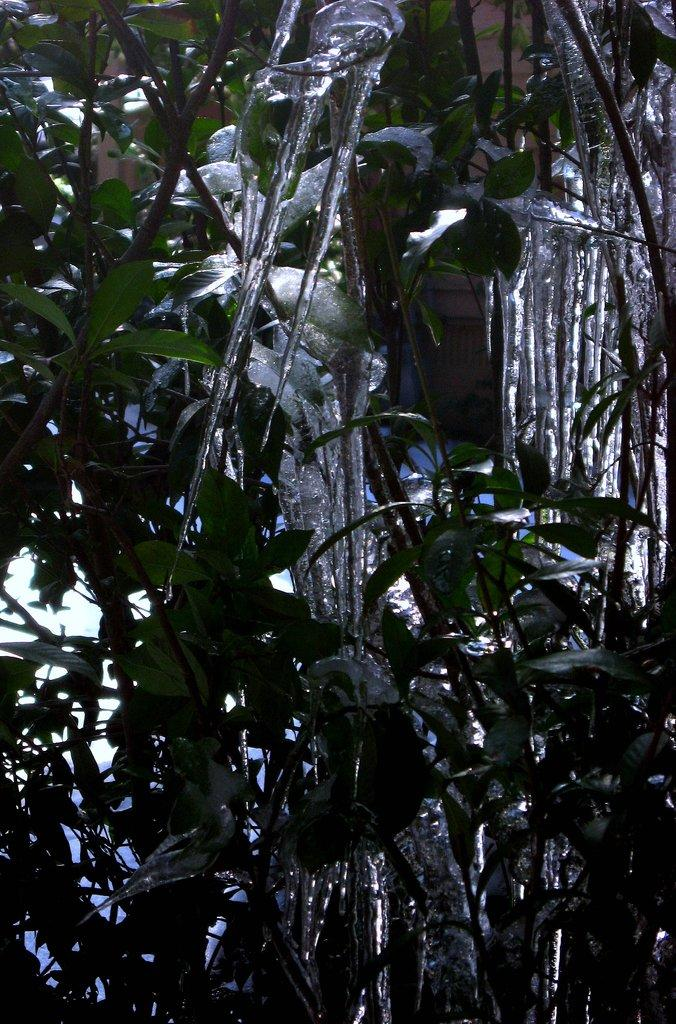What type of natural elements can be seen in the image? There are leaves in the image. What is the color of the object that may be ice? The object is white in color. Can you describe the object that may be ice? The object may be ice, but it is not explicitly stated in the facts. What type of elbow is visible in the image? There is no elbow present in the image. Can you provide a suggestion for a car model that would fit in the image? There is no car present in the image, so it is not possible to suggest a car model that would fit. 